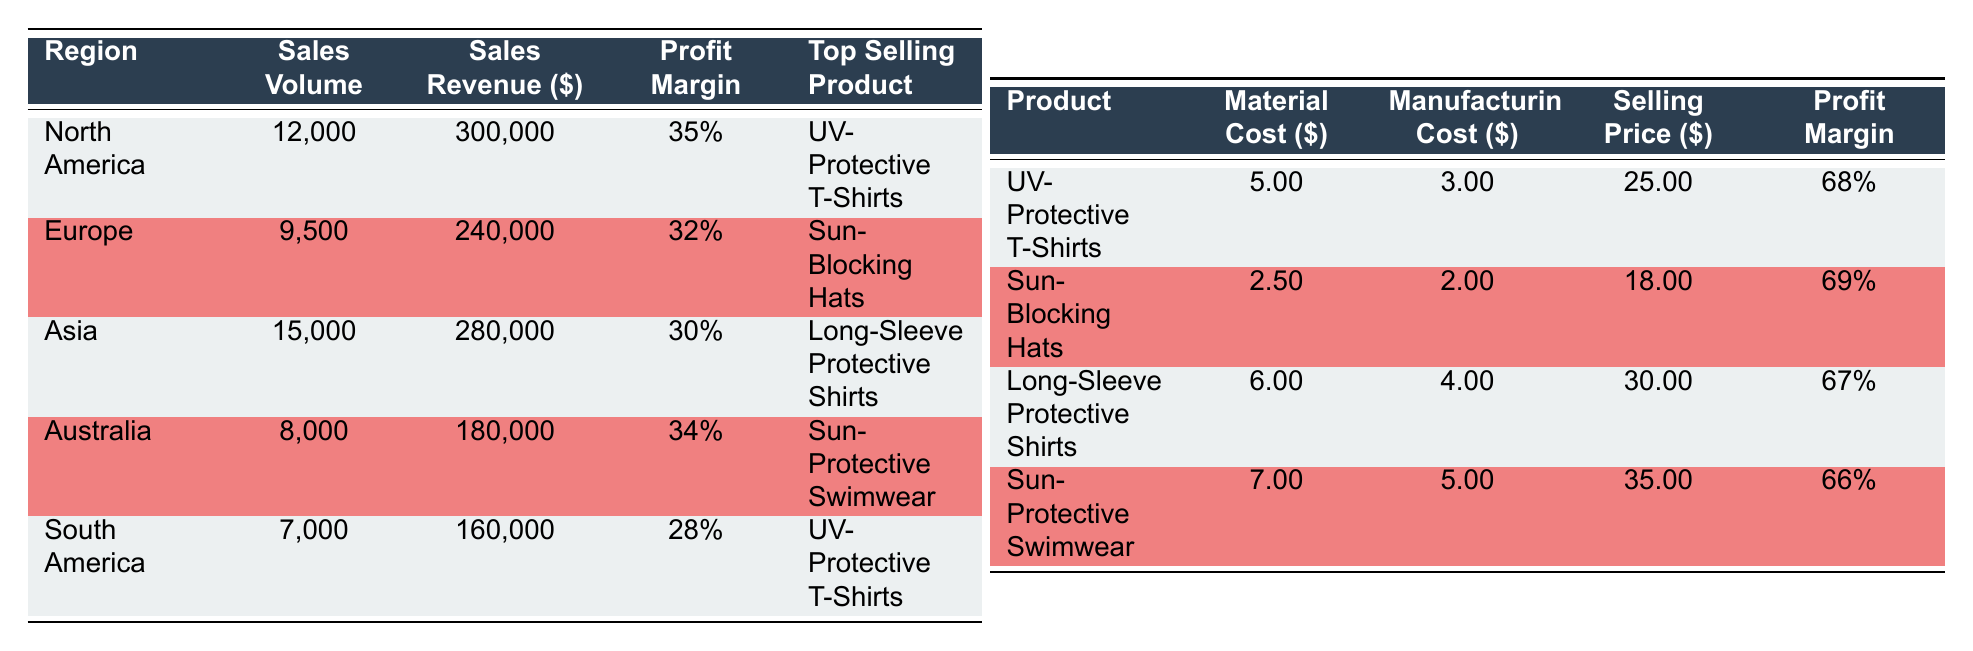What is the top-selling product in North America? According to the table, the top-selling product in North America is listed in the corresponding row under "Top Selling Product." It states that the product is "UV-Protective T-Shirts."
Answer: UV-Protective T-Shirts What is the sales revenue from Australia? The sales revenue is specified in the row for Australia under the "Sales Revenue ($)" column, which shows that the sales revenue is 180,000.
Answer: 180000 What is the profit margin for Sun-Blocking Hats? The profit margin can be found in the row for Sun-Blocking Hats under the "Profit Margin" column, which indicates a profit margin of 69%.
Answer: 69% Which region has the highest sales volume? To determine this, compare the sales volumes across all regions listed. The highest sales volume is found in North America at 12,000.
Answer: North America What are the average profit margins of the products listed? To find the average profit margin, sum the profit margins of all listed products: (0.68 + 0.69 + 0.67 + 0.66) = 2.70. Then divide by the number of products (4): 2.70 / 4 = 0.675, or 67.5%.
Answer: 67.5% Is the profit margin for Asia higher than for South America? Comparing the profit margins listed, Asia has a profit margin of 30% while South America’s profit margin is 28%. Since 30% is greater than 28%, the statement is true.
Answer: Yes What is the total sales revenue for North America and Europe combined? To find this total, add both sales revenues: North America (300,000) + Europe (240,000) = 540,000.
Answer: 540000 Which product has the highest selling price? A comparison of the selling prices in the table indicates that the product with the highest selling price is "Sun-Protective Swimwear," which is priced at 35.00.
Answer: Sun-Protective Swimwear Has South America sold more units than Australia? Compare the sales volume: South America sold 7,000 units, while Australia sold 8,000 units. Since 7,000 is less than 8,000, the statement is false.
Answer: No 